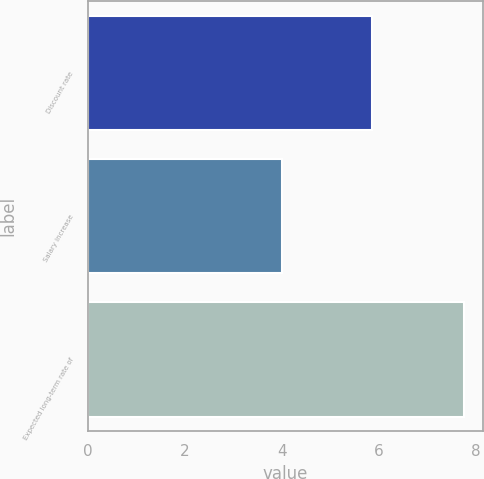Convert chart. <chart><loc_0><loc_0><loc_500><loc_500><bar_chart><fcel>Discount rate<fcel>Salary increase<fcel>Expected long-term rate of<nl><fcel>5.85<fcel>4<fcel>7.75<nl></chart> 